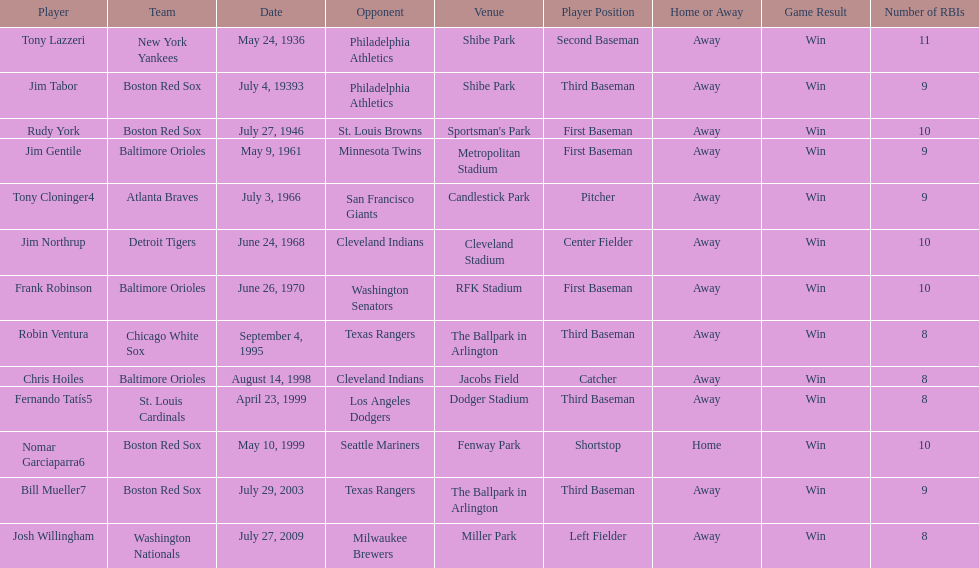What is the number of times a boston red sox player has had two grand slams in one game? 4. 